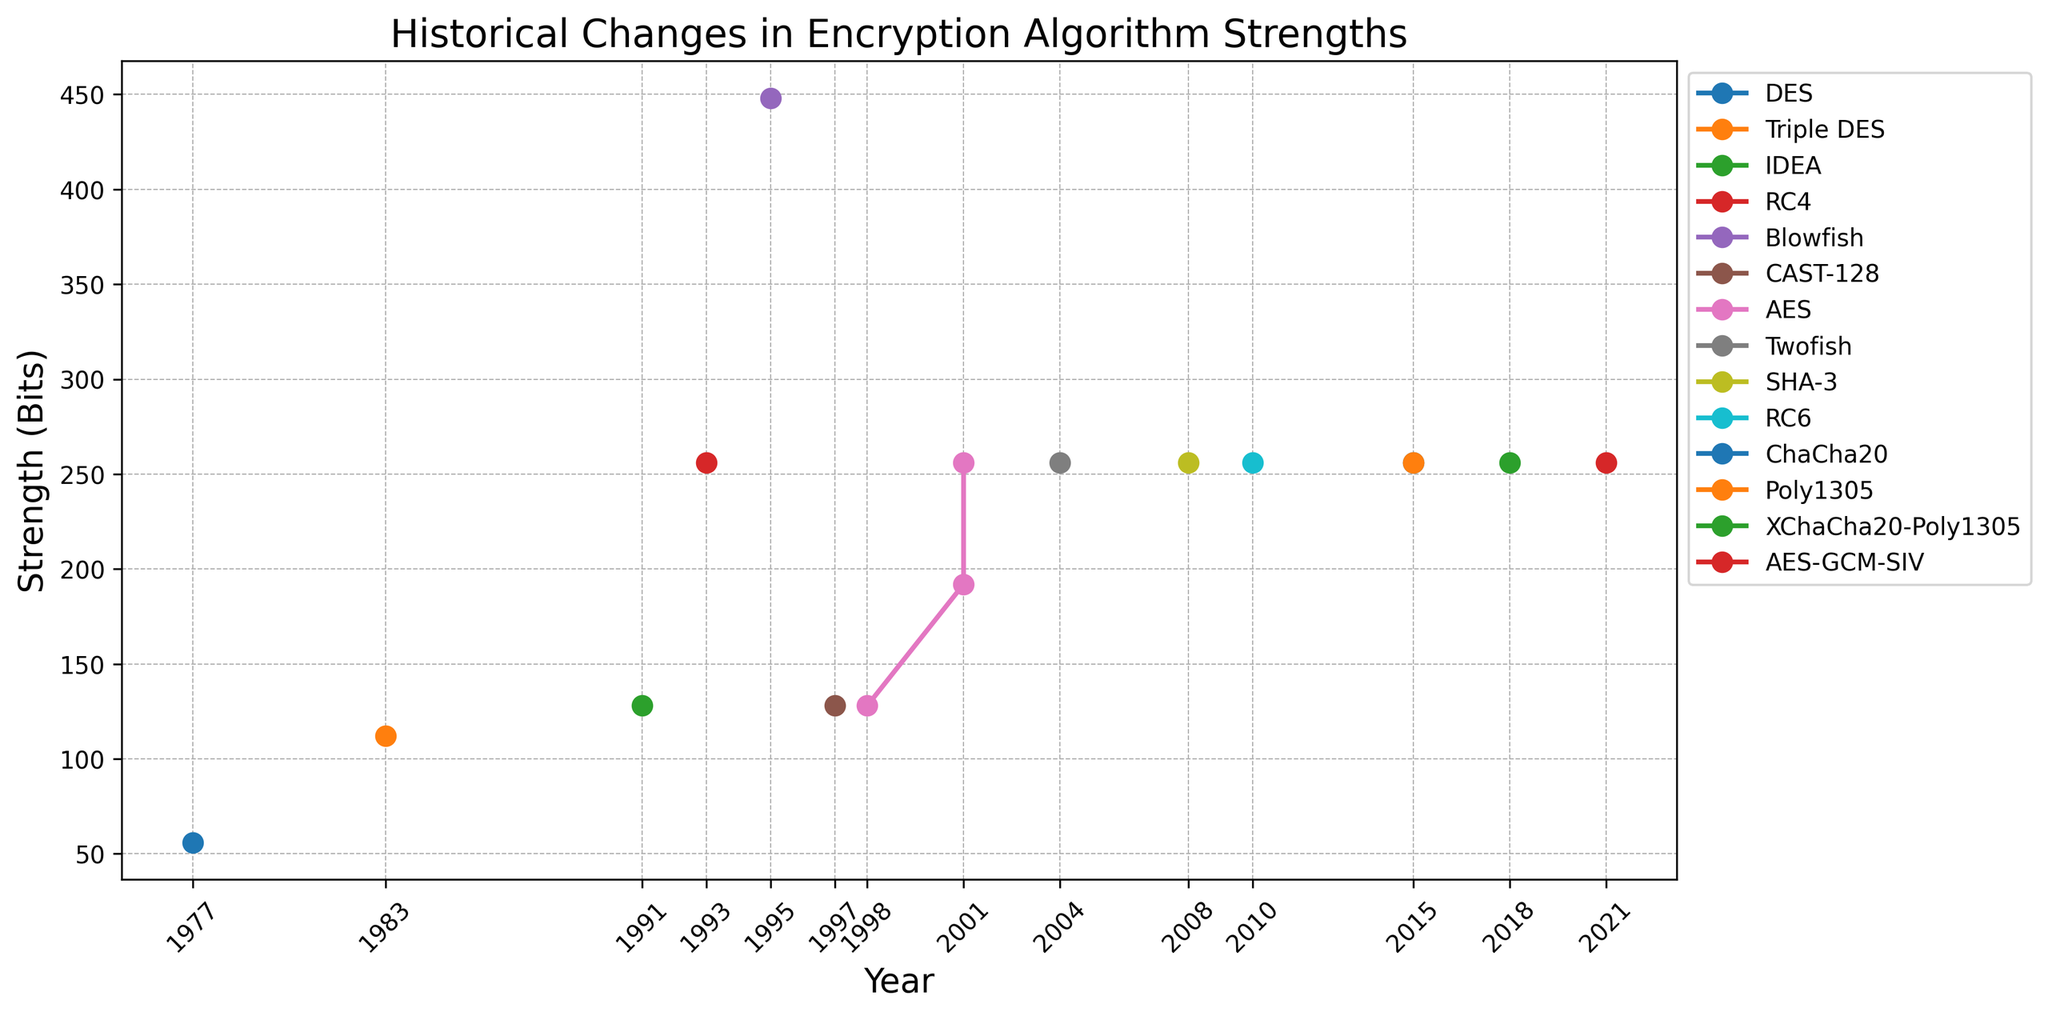Which algorithm had the highest strength in 1995? By looking at the point marked in 1995 on the line chart, we can observe the value of the strength and the corresponding algorithm.
Answer: Blowfish Has there been any algorithm with a strength lower than 128 bits after 1997? Evaluate the strengths of various algorithms from 1997 onward. If none of them have a strength lower than 128 bits, the answer is no.
Answer: No How did the strength of AES change over time? Follow the line representing AES and observe the strengths at each point in time: 128 bits in 1998, 192 bits in 2001, and 256 bits also in 2001.
Answer: Increased from 128 to 256 bits Which year introduced multiple algorithms with the same strength? Identify years when the plot shows more than one algorithm sharing the same strength. For instance, in 2001, AES appeared with different strengths but ultimately achieved 256 bits just like RC6 later on.
Answer: 2001 What is the median strength of the algorithms launched up to and including the year 2000? List the strengths of the algorithms up to the year 2000 (56, 112, 128, 256, 448, 128, 128), then sort them to find the median. The sorted list is (56, 112, 128, 128, 128, 256, 448); the median value here is the middle value.
Answer: 128 How many algorithms introduced after 2000 have low vulnerability? Review the data points after the year 2000 and count the number of algorithms that are marked with "Low" vulnerability.
Answer: 7 Compared to 1977, how much did the algorithm strength improve by 2018? Subtract the strength value of the algorithm in 1977 (DES, 56 bits) from the strength value in 2018 (XChaCha20-Poly1305, 256 bits).
Answer: 200 bits Which algorithm showed the highest increase in strength in a single year? Compare the strengths of each algorithm over time and identify the one with the most significant increase in a single transition. AES from 128 bits in 1998 to 256 bits in 2001 presents the largest leap.
Answer: AES What is the range of strengths for the algorithms introduced up to 2021? Identify the minimum and maximum strengths over the years and calculate the difference between them. The strengths range from 56 bits (DES) to 256 bits (multiple algorithms).
Answer: 200 bits 